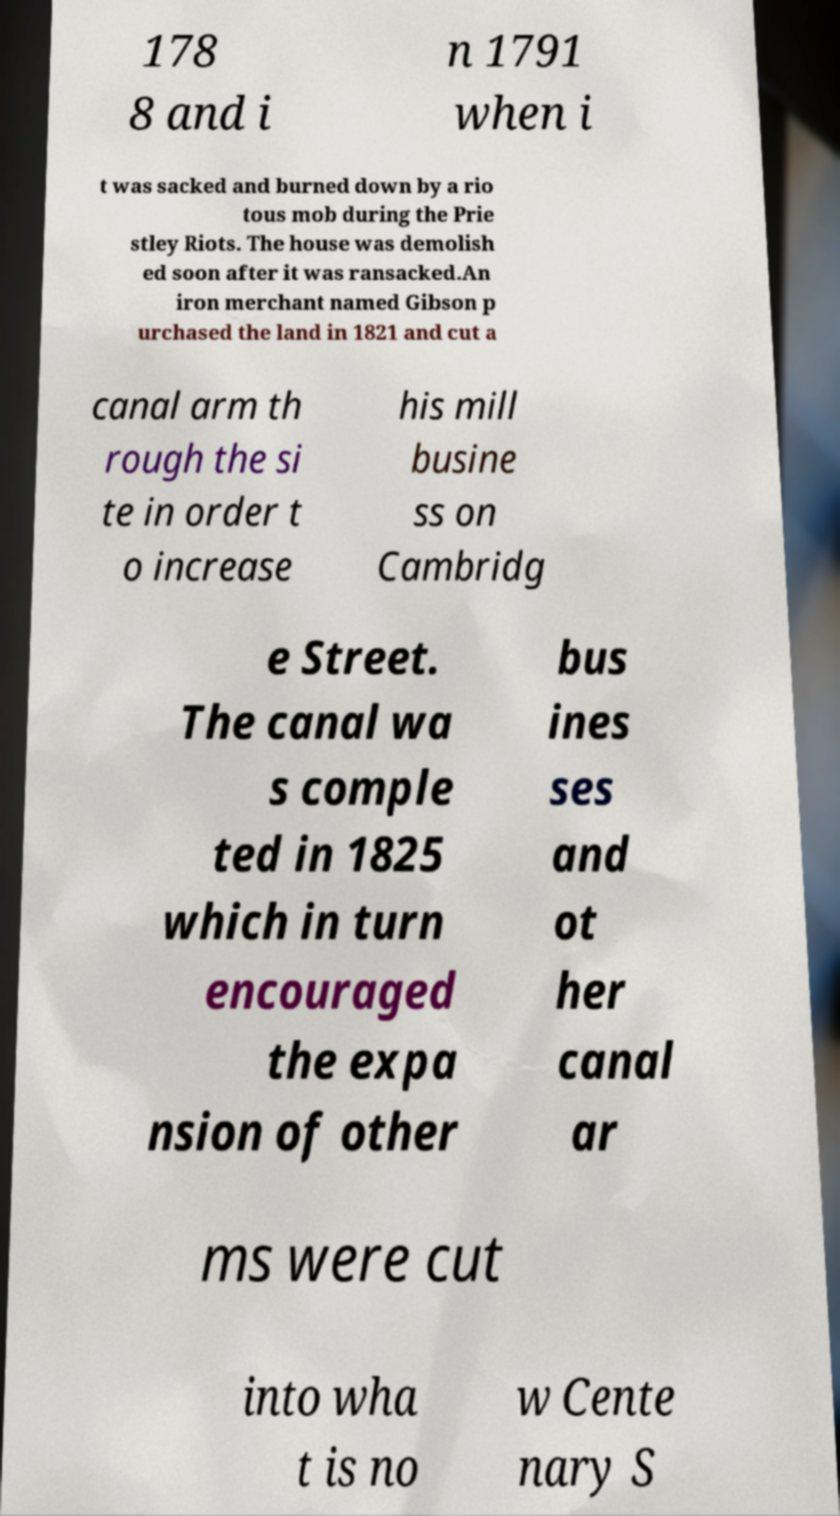What messages or text are displayed in this image? I need them in a readable, typed format. 178 8 and i n 1791 when i t was sacked and burned down by a rio tous mob during the Prie stley Riots. The house was demolish ed soon after it was ransacked.An iron merchant named Gibson p urchased the land in 1821 and cut a canal arm th rough the si te in order t o increase his mill busine ss on Cambridg e Street. The canal wa s comple ted in 1825 which in turn encouraged the expa nsion of other bus ines ses and ot her canal ar ms were cut into wha t is no w Cente nary S 